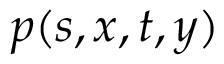<formula> <loc_0><loc_0><loc_500><loc_500>p ( s , x , t , y )</formula> 